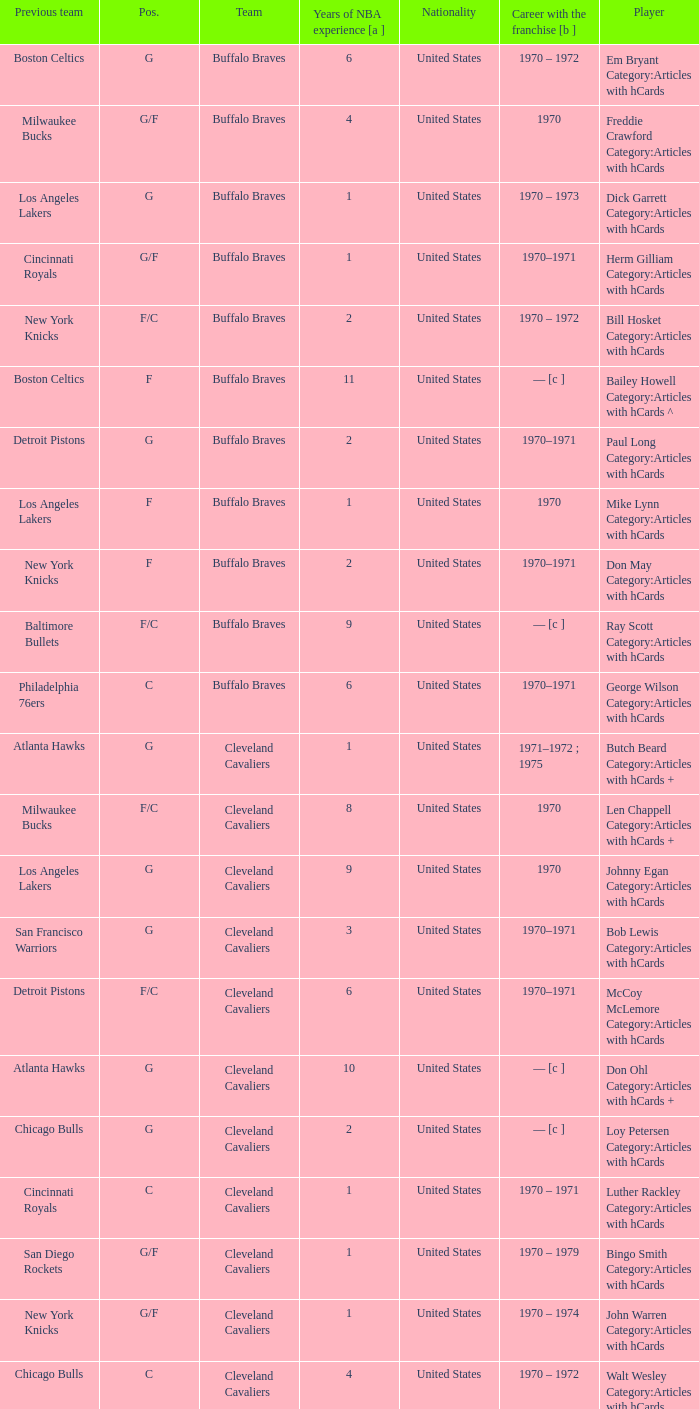How many years of NBA experience does the player who plays position g for the Portland Trail Blazers? 2.0. 